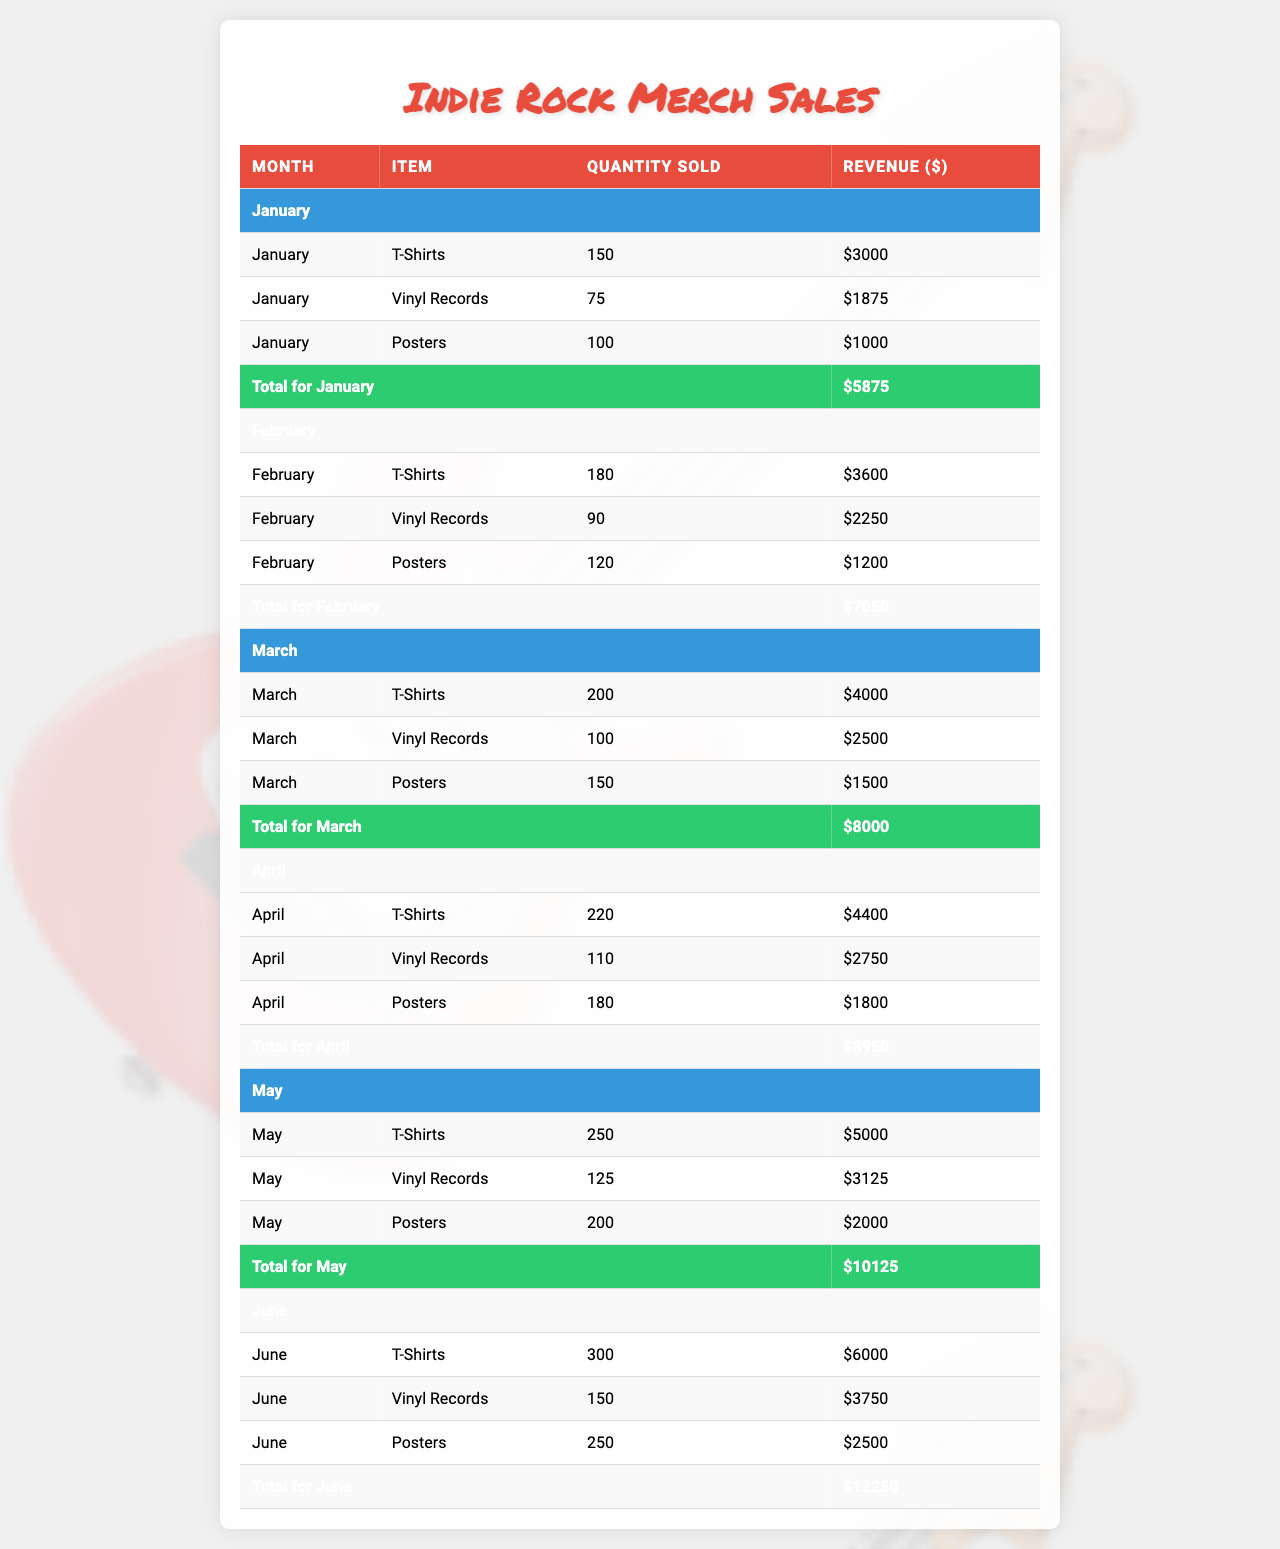What was the total revenue from T-Shirt sales in March? In March, the revenue from T-Shirt sales is listed as $4,000 in the table.
Answer: $4,000 Which merchandise item had the highest total revenue in June? In June, the revenue for T-Shirts is $6,000, Vinyl Records is $3,750, and Posters is $2,500. The highest revenue is from T-Shirts.
Answer: T-Shirts How many Vinyl Records were sold in February? The table indicates that 90 Vinyl Records were sold in February.
Answer: 90 What is the average revenue from poster sales from January to June? The total revenue from posters in the six months is (1000 + 1200 + 1500 + 1800 + 2000 + 2500) = 10000. There are 6 months, so the average is 10000 / 6 ≈ 1666.67.
Answer: $1,666.67 Was the total revenue from T-Shirts in April greater than that in March? The revenue from T-Shirts in April is $4,400 and in March, it is $4,000. Since $4,400 > $4,000, the statement is true.
Answer: Yes What was the total revenue for all merchandise items in May? In May, the revenues are T-Shirts $5,000, Vinyl Records $3,125, and Posters $2,000. Summing these gives $5,000 + $3,125 + $2,000 = $10,125.
Answer: $10,125 How many more posters were sold in May compared to January? In January, 100 posters were sold and in May, 200 posters were sold. The difference is 200 - 100 = 100.
Answer: 100 What was the total quantity sold across all months for Vinyl Records? The total quantity for Vinyl Records across all months is 75 + 90 + 100 + 110 + 125 + 150 = 650.
Answer: 650 Which month had the highest combined revenue from all merchandise items? The combined revenue for each month is calculated as follows: January $5,875, February $8,850, March $10,000, April $9,950, May $10,125, and June $11,250. June has the highest total of $11,250.
Answer: June Did the sales of T-Shirts increase every month from January to June? The sales numbers for T-Shirts are 150 (Jan), 180 (Feb), 200 (Mar), 220 (Apr), 250 (May), 300 (Jun). Since all values increase, the answer is yes.
Answer: Yes 